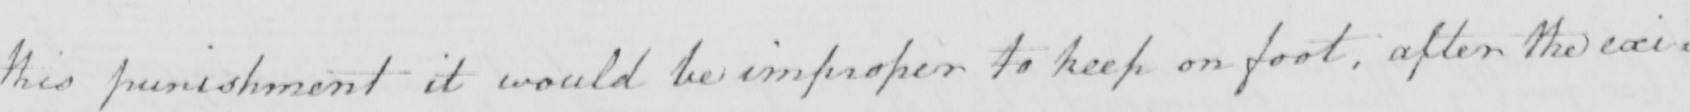Please provide the text content of this handwritten line. this punishment it would be improper to keep on foot , after the exi= 